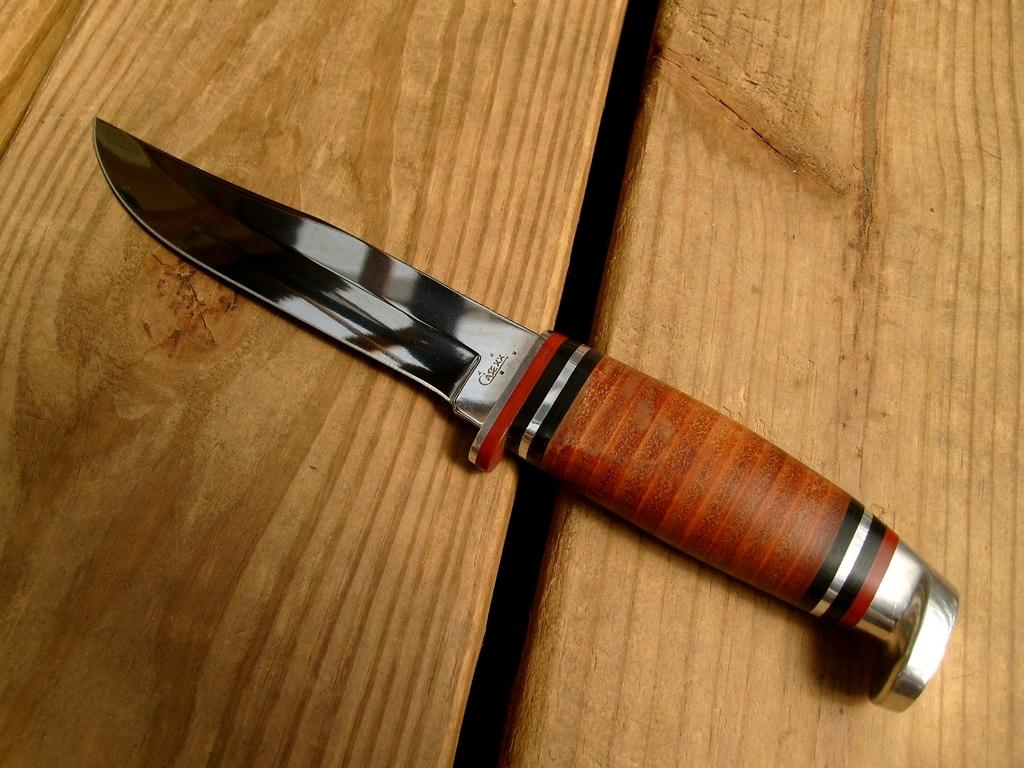What piece of furniture is present in the image? There is a table in the image. What object can be seen on the table? There is a knife on the table. How many wrens are sitting on the knife in the image? There are no wrens present in the image, and the knife is not depicted as having any birds on it. 